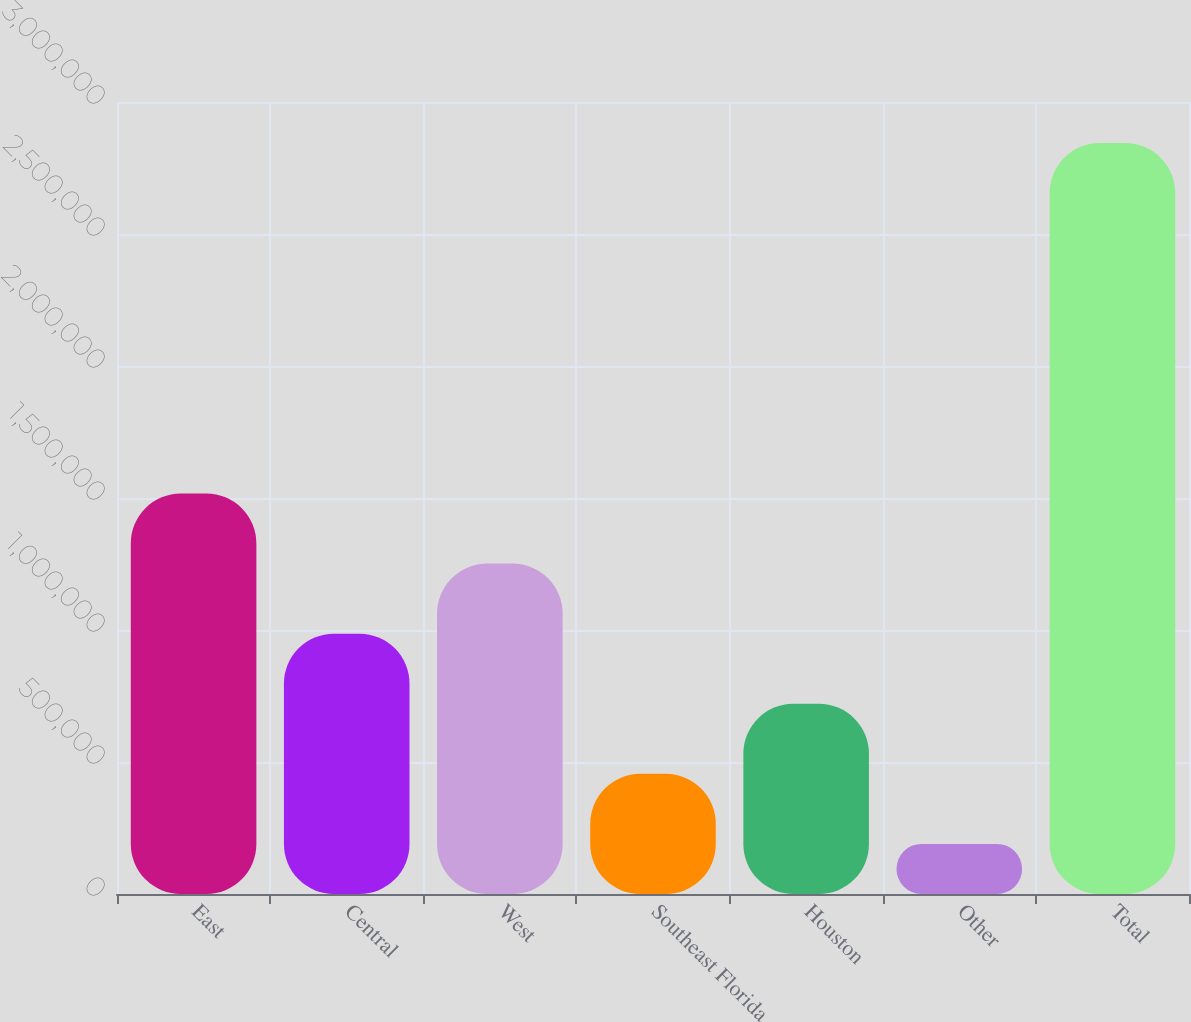<chart> <loc_0><loc_0><loc_500><loc_500><bar_chart><fcel>East<fcel>Central<fcel>West<fcel>Southeast Florida<fcel>Houston<fcel>Other<fcel>Total<nl><fcel>1.51705e+06<fcel>986093<fcel>1.25157e+06<fcel>455136<fcel>720615<fcel>189658<fcel>2.84444e+06<nl></chart> 